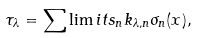<formula> <loc_0><loc_0><loc_500><loc_500>\tau _ { \lambda } = \sum \lim i t s _ { n } k _ { \lambda , n } \sigma _ { n } ( x ) ,</formula> 